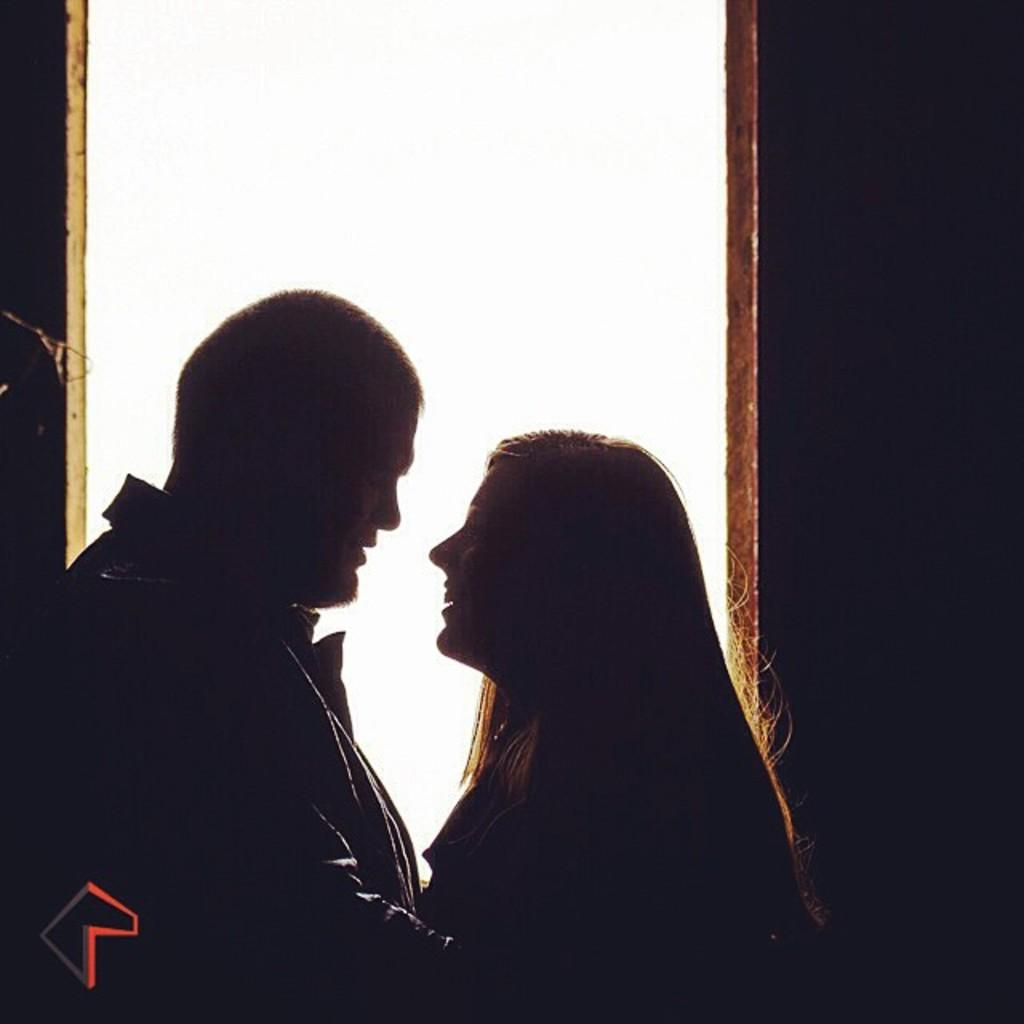Who are the subjects in the image? There is a boy and a girl in the image. Where are the boy and the girl located in the image? Both the boy and the girl are in the center of the image. What type of precipitation is falling in the image? There is no precipitation visible in the image. What causes the boy and the girl to stop in the image? The image does not show any reason for the boy and the girl to stop, as they are simply standing in the center. 